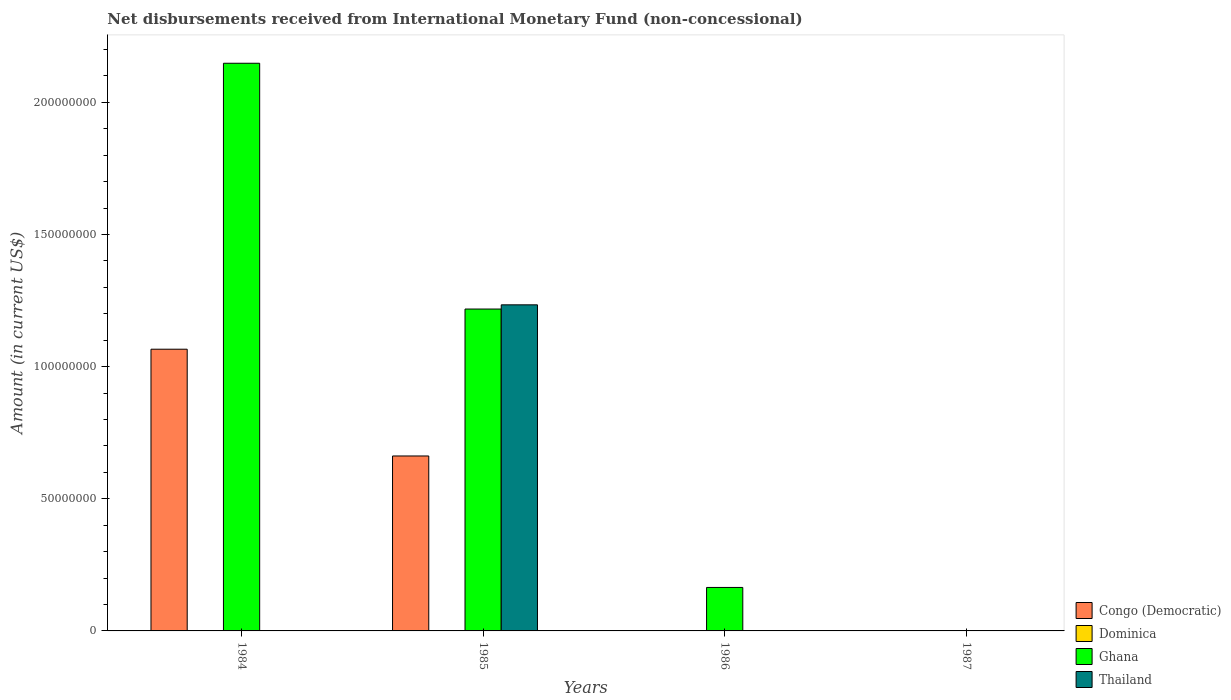How many different coloured bars are there?
Offer a very short reply. 3. What is the amount of disbursements received from International Monetary Fund in Dominica in 1984?
Give a very brief answer. 0. In which year was the amount of disbursements received from International Monetary Fund in Congo (Democratic) maximum?
Your answer should be compact. 1984. What is the total amount of disbursements received from International Monetary Fund in Congo (Democratic) in the graph?
Your answer should be compact. 1.73e+08. What is the difference between the amount of disbursements received from International Monetary Fund in Ghana in 1985 and that in 1986?
Keep it short and to the point. 1.05e+08. What is the difference between the amount of disbursements received from International Monetary Fund in Congo (Democratic) in 1986 and the amount of disbursements received from International Monetary Fund in Ghana in 1985?
Your response must be concise. -1.22e+08. What is the average amount of disbursements received from International Monetary Fund in Congo (Democratic) per year?
Give a very brief answer. 4.32e+07. In the year 1985, what is the difference between the amount of disbursements received from International Monetary Fund in Ghana and amount of disbursements received from International Monetary Fund in Congo (Democratic)?
Provide a short and direct response. 5.56e+07. In how many years, is the amount of disbursements received from International Monetary Fund in Ghana greater than 140000000 US$?
Your answer should be compact. 1. What is the ratio of the amount of disbursements received from International Monetary Fund in Congo (Democratic) in 1984 to that in 1985?
Provide a succinct answer. 1.61. What is the difference between the highest and the lowest amount of disbursements received from International Monetary Fund in Congo (Democratic)?
Make the answer very short. 1.07e+08. Is it the case that in every year, the sum of the amount of disbursements received from International Monetary Fund in Thailand and amount of disbursements received from International Monetary Fund in Congo (Democratic) is greater than the sum of amount of disbursements received from International Monetary Fund in Dominica and amount of disbursements received from International Monetary Fund in Ghana?
Offer a terse response. No. Is it the case that in every year, the sum of the amount of disbursements received from International Monetary Fund in Ghana and amount of disbursements received from International Monetary Fund in Congo (Democratic) is greater than the amount of disbursements received from International Monetary Fund in Thailand?
Your answer should be compact. No. Are all the bars in the graph horizontal?
Give a very brief answer. No. How many years are there in the graph?
Keep it short and to the point. 4. Are the values on the major ticks of Y-axis written in scientific E-notation?
Make the answer very short. No. How are the legend labels stacked?
Ensure brevity in your answer.  Vertical. What is the title of the graph?
Provide a succinct answer. Net disbursements received from International Monetary Fund (non-concessional). Does "Haiti" appear as one of the legend labels in the graph?
Keep it short and to the point. No. What is the label or title of the X-axis?
Your answer should be compact. Years. What is the label or title of the Y-axis?
Your answer should be very brief. Amount (in current US$). What is the Amount (in current US$) of Congo (Democratic) in 1984?
Give a very brief answer. 1.07e+08. What is the Amount (in current US$) in Dominica in 1984?
Ensure brevity in your answer.  0. What is the Amount (in current US$) of Ghana in 1984?
Your response must be concise. 2.15e+08. What is the Amount (in current US$) of Congo (Democratic) in 1985?
Make the answer very short. 6.62e+07. What is the Amount (in current US$) in Dominica in 1985?
Provide a succinct answer. 0. What is the Amount (in current US$) in Ghana in 1985?
Give a very brief answer. 1.22e+08. What is the Amount (in current US$) of Thailand in 1985?
Offer a very short reply. 1.23e+08. What is the Amount (in current US$) of Congo (Democratic) in 1986?
Make the answer very short. 0. What is the Amount (in current US$) of Dominica in 1986?
Your answer should be very brief. 0. What is the Amount (in current US$) of Ghana in 1986?
Keep it short and to the point. 1.64e+07. What is the Amount (in current US$) of Congo (Democratic) in 1987?
Give a very brief answer. 0. What is the Amount (in current US$) in Dominica in 1987?
Provide a succinct answer. 0. What is the Amount (in current US$) of Ghana in 1987?
Offer a terse response. 0. What is the Amount (in current US$) of Thailand in 1987?
Your response must be concise. 0. Across all years, what is the maximum Amount (in current US$) of Congo (Democratic)?
Your answer should be compact. 1.07e+08. Across all years, what is the maximum Amount (in current US$) in Ghana?
Your response must be concise. 2.15e+08. Across all years, what is the maximum Amount (in current US$) in Thailand?
Provide a succinct answer. 1.23e+08. Across all years, what is the minimum Amount (in current US$) in Congo (Democratic)?
Provide a short and direct response. 0. Across all years, what is the minimum Amount (in current US$) in Ghana?
Ensure brevity in your answer.  0. What is the total Amount (in current US$) in Congo (Democratic) in the graph?
Your answer should be compact. 1.73e+08. What is the total Amount (in current US$) in Ghana in the graph?
Provide a short and direct response. 3.53e+08. What is the total Amount (in current US$) in Thailand in the graph?
Provide a succinct answer. 1.23e+08. What is the difference between the Amount (in current US$) in Congo (Democratic) in 1984 and that in 1985?
Your answer should be compact. 4.04e+07. What is the difference between the Amount (in current US$) of Ghana in 1984 and that in 1985?
Your answer should be compact. 9.30e+07. What is the difference between the Amount (in current US$) in Ghana in 1984 and that in 1986?
Provide a short and direct response. 1.98e+08. What is the difference between the Amount (in current US$) of Ghana in 1985 and that in 1986?
Give a very brief answer. 1.05e+08. What is the difference between the Amount (in current US$) of Congo (Democratic) in 1984 and the Amount (in current US$) of Ghana in 1985?
Offer a terse response. -1.52e+07. What is the difference between the Amount (in current US$) of Congo (Democratic) in 1984 and the Amount (in current US$) of Thailand in 1985?
Give a very brief answer. -1.68e+07. What is the difference between the Amount (in current US$) in Ghana in 1984 and the Amount (in current US$) in Thailand in 1985?
Keep it short and to the point. 9.14e+07. What is the difference between the Amount (in current US$) of Congo (Democratic) in 1984 and the Amount (in current US$) of Ghana in 1986?
Keep it short and to the point. 9.02e+07. What is the difference between the Amount (in current US$) in Congo (Democratic) in 1985 and the Amount (in current US$) in Ghana in 1986?
Provide a succinct answer. 4.98e+07. What is the average Amount (in current US$) in Congo (Democratic) per year?
Offer a terse response. 4.32e+07. What is the average Amount (in current US$) of Dominica per year?
Your answer should be compact. 0. What is the average Amount (in current US$) in Ghana per year?
Offer a terse response. 8.83e+07. What is the average Amount (in current US$) in Thailand per year?
Provide a short and direct response. 3.08e+07. In the year 1984, what is the difference between the Amount (in current US$) of Congo (Democratic) and Amount (in current US$) of Ghana?
Offer a terse response. -1.08e+08. In the year 1985, what is the difference between the Amount (in current US$) in Congo (Democratic) and Amount (in current US$) in Ghana?
Offer a terse response. -5.56e+07. In the year 1985, what is the difference between the Amount (in current US$) in Congo (Democratic) and Amount (in current US$) in Thailand?
Offer a terse response. -5.72e+07. In the year 1985, what is the difference between the Amount (in current US$) of Ghana and Amount (in current US$) of Thailand?
Make the answer very short. -1.59e+06. What is the ratio of the Amount (in current US$) in Congo (Democratic) in 1984 to that in 1985?
Keep it short and to the point. 1.61. What is the ratio of the Amount (in current US$) of Ghana in 1984 to that in 1985?
Offer a very short reply. 1.76. What is the ratio of the Amount (in current US$) of Ghana in 1984 to that in 1986?
Offer a very short reply. 13.06. What is the ratio of the Amount (in current US$) of Ghana in 1985 to that in 1986?
Provide a short and direct response. 7.4. What is the difference between the highest and the second highest Amount (in current US$) in Ghana?
Keep it short and to the point. 9.30e+07. What is the difference between the highest and the lowest Amount (in current US$) of Congo (Democratic)?
Your answer should be compact. 1.07e+08. What is the difference between the highest and the lowest Amount (in current US$) of Ghana?
Make the answer very short. 2.15e+08. What is the difference between the highest and the lowest Amount (in current US$) in Thailand?
Your response must be concise. 1.23e+08. 